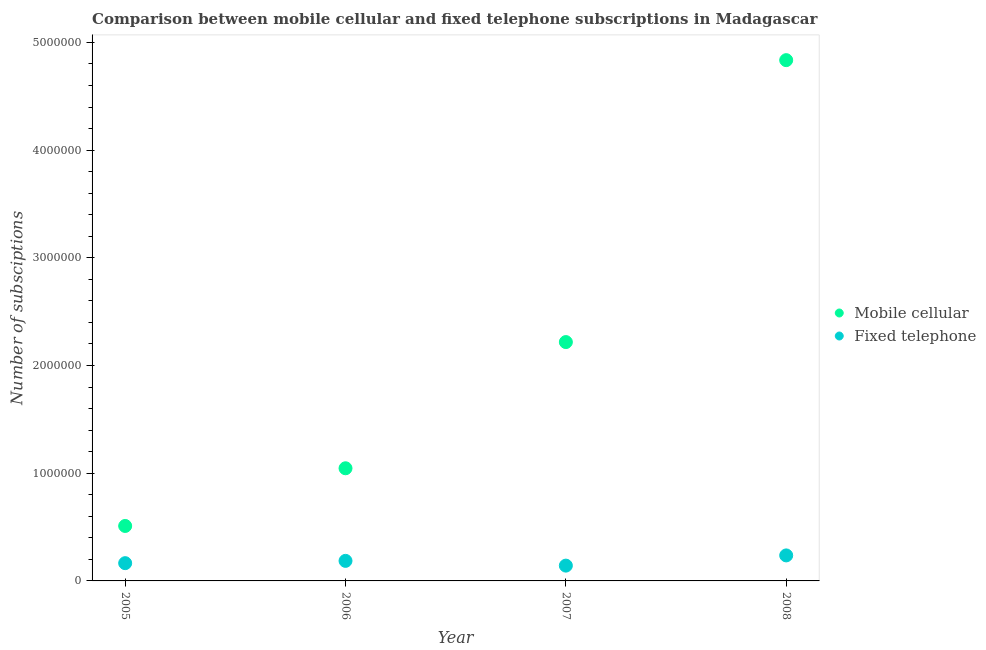What is the number of mobile cellular subscriptions in 2005?
Ensure brevity in your answer.  5.10e+05. Across all years, what is the maximum number of mobile cellular subscriptions?
Provide a succinct answer. 4.84e+06. Across all years, what is the minimum number of mobile cellular subscriptions?
Ensure brevity in your answer.  5.10e+05. In which year was the number of mobile cellular subscriptions maximum?
Provide a succinct answer. 2008. In which year was the number of fixed telephone subscriptions minimum?
Offer a very short reply. 2007. What is the total number of fixed telephone subscriptions in the graph?
Make the answer very short. 7.30e+05. What is the difference between the number of mobile cellular subscriptions in 2005 and that in 2007?
Provide a short and direct response. -1.71e+06. What is the difference between the number of mobile cellular subscriptions in 2007 and the number of fixed telephone subscriptions in 2008?
Your response must be concise. 1.98e+06. What is the average number of mobile cellular subscriptions per year?
Provide a short and direct response. 2.15e+06. In the year 2007, what is the difference between the number of fixed telephone subscriptions and number of mobile cellular subscriptions?
Offer a very short reply. -2.08e+06. What is the ratio of the number of mobile cellular subscriptions in 2006 to that in 2007?
Ensure brevity in your answer.  0.47. What is the difference between the highest and the second highest number of mobile cellular subscriptions?
Make the answer very short. 2.62e+06. What is the difference between the highest and the lowest number of fixed telephone subscriptions?
Give a very brief answer. 9.48e+04. Does the number of mobile cellular subscriptions monotonically increase over the years?
Offer a terse response. Yes. Is the number of fixed telephone subscriptions strictly greater than the number of mobile cellular subscriptions over the years?
Keep it short and to the point. No. Is the number of mobile cellular subscriptions strictly less than the number of fixed telephone subscriptions over the years?
Make the answer very short. No. How many dotlines are there?
Ensure brevity in your answer.  2. How many years are there in the graph?
Your answer should be very brief. 4. Does the graph contain any zero values?
Ensure brevity in your answer.  No. Where does the legend appear in the graph?
Give a very brief answer. Center right. What is the title of the graph?
Your answer should be very brief. Comparison between mobile cellular and fixed telephone subscriptions in Madagascar. What is the label or title of the X-axis?
Make the answer very short. Year. What is the label or title of the Y-axis?
Your answer should be very brief. Number of subsciptions. What is the Number of subsciptions in Mobile cellular in 2005?
Offer a very short reply. 5.10e+05. What is the Number of subsciptions of Fixed telephone in 2005?
Your answer should be compact. 1.65e+05. What is the Number of subsciptions in Mobile cellular in 2006?
Ensure brevity in your answer.  1.05e+06. What is the Number of subsciptions in Fixed telephone in 2006?
Make the answer very short. 1.86e+05. What is the Number of subsciptions of Mobile cellular in 2007?
Provide a succinct answer. 2.22e+06. What is the Number of subsciptions of Fixed telephone in 2007?
Give a very brief answer. 1.42e+05. What is the Number of subsciptions in Mobile cellular in 2008?
Offer a very short reply. 4.84e+06. What is the Number of subsciptions in Fixed telephone in 2008?
Give a very brief answer. 2.37e+05. Across all years, what is the maximum Number of subsciptions of Mobile cellular?
Keep it short and to the point. 4.84e+06. Across all years, what is the maximum Number of subsciptions of Fixed telephone?
Your answer should be very brief. 2.37e+05. Across all years, what is the minimum Number of subsciptions of Mobile cellular?
Make the answer very short. 5.10e+05. Across all years, what is the minimum Number of subsciptions of Fixed telephone?
Ensure brevity in your answer.  1.42e+05. What is the total Number of subsciptions in Mobile cellular in the graph?
Provide a succinct answer. 8.61e+06. What is the total Number of subsciptions of Fixed telephone in the graph?
Provide a short and direct response. 7.30e+05. What is the difference between the Number of subsciptions in Mobile cellular in 2005 and that in 2006?
Your response must be concise. -5.36e+05. What is the difference between the Number of subsciptions in Fixed telephone in 2005 and that in 2006?
Your response must be concise. -2.13e+04. What is the difference between the Number of subsciptions of Mobile cellular in 2005 and that in 2007?
Give a very brief answer. -1.71e+06. What is the difference between the Number of subsciptions of Fixed telephone in 2005 and that in 2007?
Give a very brief answer. 2.28e+04. What is the difference between the Number of subsciptions of Mobile cellular in 2005 and that in 2008?
Keep it short and to the point. -4.32e+06. What is the difference between the Number of subsciptions of Fixed telephone in 2005 and that in 2008?
Provide a short and direct response. -7.20e+04. What is the difference between the Number of subsciptions in Mobile cellular in 2006 and that in 2007?
Your answer should be very brief. -1.17e+06. What is the difference between the Number of subsciptions in Fixed telephone in 2006 and that in 2007?
Make the answer very short. 4.41e+04. What is the difference between the Number of subsciptions in Mobile cellular in 2006 and that in 2008?
Make the answer very short. -3.79e+06. What is the difference between the Number of subsciptions in Fixed telephone in 2006 and that in 2008?
Provide a short and direct response. -5.07e+04. What is the difference between the Number of subsciptions in Mobile cellular in 2007 and that in 2008?
Your answer should be compact. -2.62e+06. What is the difference between the Number of subsciptions in Fixed telephone in 2007 and that in 2008?
Offer a terse response. -9.48e+04. What is the difference between the Number of subsciptions in Mobile cellular in 2005 and the Number of subsciptions in Fixed telephone in 2006?
Make the answer very short. 3.24e+05. What is the difference between the Number of subsciptions of Mobile cellular in 2005 and the Number of subsciptions of Fixed telephone in 2007?
Offer a very short reply. 3.68e+05. What is the difference between the Number of subsciptions in Mobile cellular in 2005 and the Number of subsciptions in Fixed telephone in 2008?
Offer a very short reply. 2.73e+05. What is the difference between the Number of subsciptions of Mobile cellular in 2006 and the Number of subsciptions of Fixed telephone in 2007?
Your answer should be very brief. 9.04e+05. What is the difference between the Number of subsciptions of Mobile cellular in 2006 and the Number of subsciptions of Fixed telephone in 2008?
Your answer should be compact. 8.09e+05. What is the difference between the Number of subsciptions in Mobile cellular in 2007 and the Number of subsciptions in Fixed telephone in 2008?
Ensure brevity in your answer.  1.98e+06. What is the average Number of subsciptions in Mobile cellular per year?
Provide a succinct answer. 2.15e+06. What is the average Number of subsciptions of Fixed telephone per year?
Your answer should be compact. 1.82e+05. In the year 2005, what is the difference between the Number of subsciptions in Mobile cellular and Number of subsciptions in Fixed telephone?
Ensure brevity in your answer.  3.45e+05. In the year 2006, what is the difference between the Number of subsciptions of Mobile cellular and Number of subsciptions of Fixed telephone?
Provide a succinct answer. 8.60e+05. In the year 2007, what is the difference between the Number of subsciptions of Mobile cellular and Number of subsciptions of Fixed telephone?
Your answer should be compact. 2.08e+06. In the year 2008, what is the difference between the Number of subsciptions of Mobile cellular and Number of subsciptions of Fixed telephone?
Provide a short and direct response. 4.60e+06. What is the ratio of the Number of subsciptions of Mobile cellular in 2005 to that in 2006?
Give a very brief answer. 0.49. What is the ratio of the Number of subsciptions of Fixed telephone in 2005 to that in 2006?
Give a very brief answer. 0.89. What is the ratio of the Number of subsciptions in Mobile cellular in 2005 to that in 2007?
Make the answer very short. 0.23. What is the ratio of the Number of subsciptions in Fixed telephone in 2005 to that in 2007?
Your answer should be very brief. 1.16. What is the ratio of the Number of subsciptions in Mobile cellular in 2005 to that in 2008?
Give a very brief answer. 0.11. What is the ratio of the Number of subsciptions in Fixed telephone in 2005 to that in 2008?
Your response must be concise. 0.7. What is the ratio of the Number of subsciptions of Mobile cellular in 2006 to that in 2007?
Provide a short and direct response. 0.47. What is the ratio of the Number of subsciptions of Fixed telephone in 2006 to that in 2007?
Give a very brief answer. 1.31. What is the ratio of the Number of subsciptions of Mobile cellular in 2006 to that in 2008?
Provide a short and direct response. 0.22. What is the ratio of the Number of subsciptions in Fixed telephone in 2006 to that in 2008?
Keep it short and to the point. 0.79. What is the ratio of the Number of subsciptions of Mobile cellular in 2007 to that in 2008?
Offer a terse response. 0.46. What is the ratio of the Number of subsciptions of Fixed telephone in 2007 to that in 2008?
Keep it short and to the point. 0.6. What is the difference between the highest and the second highest Number of subsciptions of Mobile cellular?
Your answer should be very brief. 2.62e+06. What is the difference between the highest and the second highest Number of subsciptions of Fixed telephone?
Make the answer very short. 5.07e+04. What is the difference between the highest and the lowest Number of subsciptions of Mobile cellular?
Your answer should be compact. 4.32e+06. What is the difference between the highest and the lowest Number of subsciptions in Fixed telephone?
Make the answer very short. 9.48e+04. 